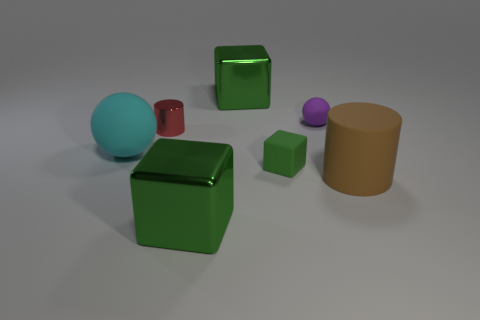Subtract all green matte cubes. How many cubes are left? 2 Subtract all blue blocks. Subtract all cyan cylinders. How many blocks are left? 3 Add 1 big brown objects. How many objects exist? 8 Subtract 0 purple cubes. How many objects are left? 7 Subtract all cylinders. How many objects are left? 5 Subtract all purple matte cylinders. Subtract all tiny objects. How many objects are left? 4 Add 2 rubber objects. How many rubber objects are left? 6 Add 2 red cylinders. How many red cylinders exist? 3 